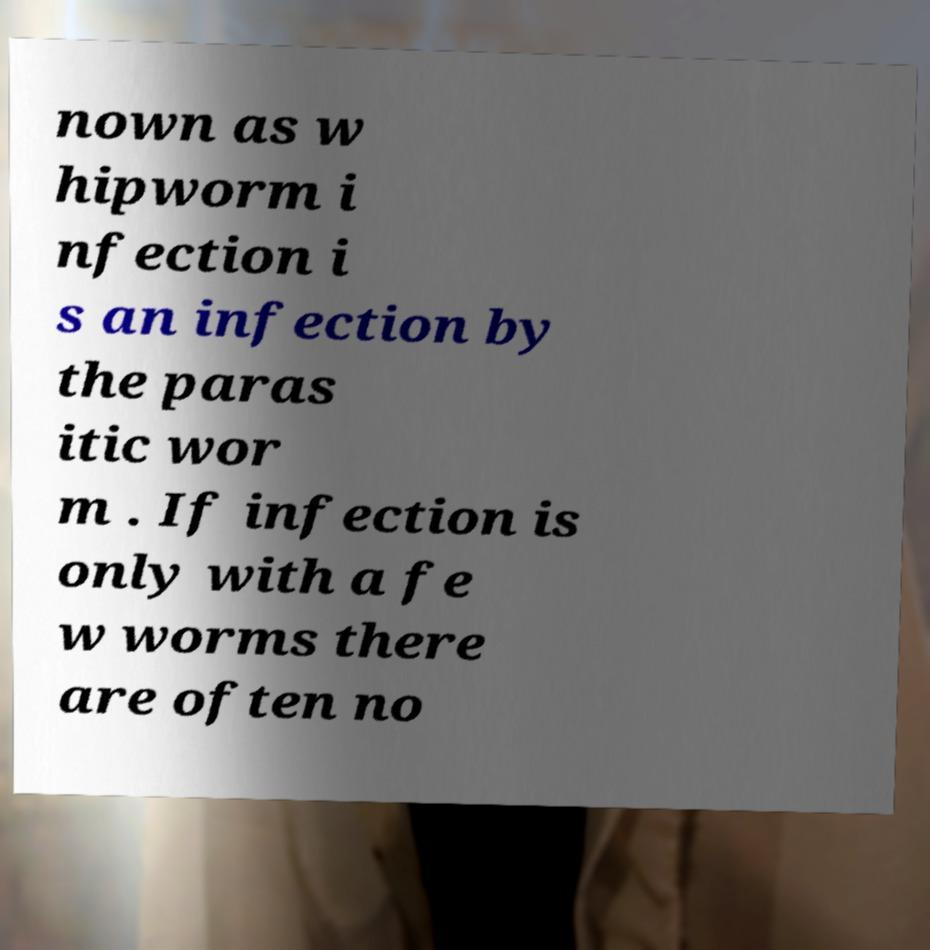Please identify and transcribe the text found in this image. nown as w hipworm i nfection i s an infection by the paras itic wor m . If infection is only with a fe w worms there are often no 